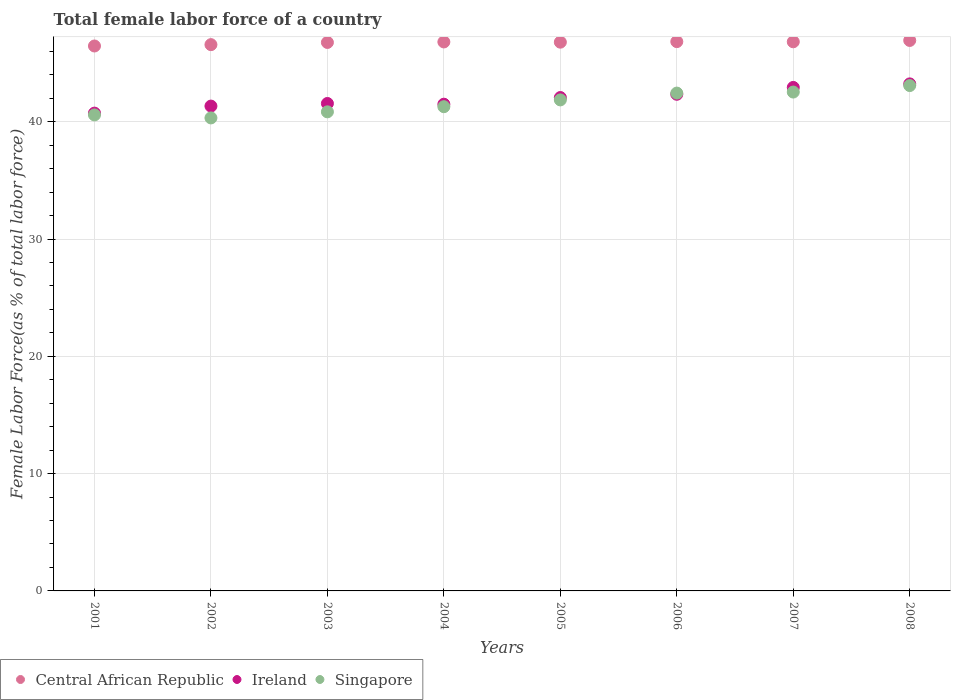Is the number of dotlines equal to the number of legend labels?
Ensure brevity in your answer.  Yes. What is the percentage of female labor force in Ireland in 2003?
Your answer should be compact. 41.55. Across all years, what is the maximum percentage of female labor force in Ireland?
Your answer should be compact. 43.22. Across all years, what is the minimum percentage of female labor force in Central African Republic?
Ensure brevity in your answer.  46.45. What is the total percentage of female labor force in Central African Republic in the graph?
Make the answer very short. 373.93. What is the difference between the percentage of female labor force in Singapore in 2001 and that in 2004?
Ensure brevity in your answer.  -0.7. What is the difference between the percentage of female labor force in Central African Republic in 2006 and the percentage of female labor force in Singapore in 2007?
Your answer should be compact. 4.3. What is the average percentage of female labor force in Central African Republic per year?
Provide a succinct answer. 46.74. In the year 2008, what is the difference between the percentage of female labor force in Singapore and percentage of female labor force in Ireland?
Give a very brief answer. -0.14. In how many years, is the percentage of female labor force in Ireland greater than 26 %?
Your response must be concise. 8. What is the ratio of the percentage of female labor force in Singapore in 2002 to that in 2004?
Offer a very short reply. 0.98. Is the percentage of female labor force in Singapore in 2006 less than that in 2008?
Your answer should be compact. Yes. What is the difference between the highest and the second highest percentage of female labor force in Singapore?
Provide a short and direct response. 0.55. What is the difference between the highest and the lowest percentage of female labor force in Singapore?
Keep it short and to the point. 2.76. In how many years, is the percentage of female labor force in Singapore greater than the average percentage of female labor force in Singapore taken over all years?
Ensure brevity in your answer.  4. Is the sum of the percentage of female labor force in Ireland in 2001 and 2003 greater than the maximum percentage of female labor force in Singapore across all years?
Your answer should be compact. Yes. Is it the case that in every year, the sum of the percentage of female labor force in Central African Republic and percentage of female labor force in Singapore  is greater than the percentage of female labor force in Ireland?
Provide a short and direct response. Yes. Is the percentage of female labor force in Central African Republic strictly greater than the percentage of female labor force in Singapore over the years?
Provide a short and direct response. Yes. How many dotlines are there?
Keep it short and to the point. 3. How many years are there in the graph?
Give a very brief answer. 8. What is the title of the graph?
Offer a terse response. Total female labor force of a country. Does "Chad" appear as one of the legend labels in the graph?
Make the answer very short. No. What is the label or title of the X-axis?
Make the answer very short. Years. What is the label or title of the Y-axis?
Offer a very short reply. Female Labor Force(as % of total labor force). What is the Female Labor Force(as % of total labor force) in Central African Republic in 2001?
Your answer should be very brief. 46.45. What is the Female Labor Force(as % of total labor force) in Ireland in 2001?
Your answer should be compact. 40.73. What is the Female Labor Force(as % of total labor force) of Singapore in 2001?
Provide a short and direct response. 40.58. What is the Female Labor Force(as % of total labor force) in Central African Republic in 2002?
Your answer should be very brief. 46.57. What is the Female Labor Force(as % of total labor force) of Ireland in 2002?
Make the answer very short. 41.33. What is the Female Labor Force(as % of total labor force) of Singapore in 2002?
Offer a terse response. 40.32. What is the Female Labor Force(as % of total labor force) in Central African Republic in 2003?
Offer a terse response. 46.76. What is the Female Labor Force(as % of total labor force) of Ireland in 2003?
Provide a short and direct response. 41.55. What is the Female Labor Force(as % of total labor force) in Singapore in 2003?
Your response must be concise. 40.84. What is the Female Labor Force(as % of total labor force) of Central African Republic in 2004?
Your answer should be compact. 46.8. What is the Female Labor Force(as % of total labor force) in Ireland in 2004?
Offer a terse response. 41.49. What is the Female Labor Force(as % of total labor force) of Singapore in 2004?
Your answer should be compact. 41.28. What is the Female Labor Force(as % of total labor force) of Central African Republic in 2005?
Offer a very short reply. 46.78. What is the Female Labor Force(as % of total labor force) of Ireland in 2005?
Provide a short and direct response. 42.06. What is the Female Labor Force(as % of total labor force) in Singapore in 2005?
Offer a very short reply. 41.86. What is the Female Labor Force(as % of total labor force) of Central African Republic in 2006?
Offer a terse response. 46.83. What is the Female Labor Force(as % of total labor force) in Ireland in 2006?
Provide a succinct answer. 42.34. What is the Female Labor Force(as % of total labor force) in Singapore in 2006?
Make the answer very short. 42.44. What is the Female Labor Force(as % of total labor force) in Central African Republic in 2007?
Your answer should be very brief. 46.81. What is the Female Labor Force(as % of total labor force) in Ireland in 2007?
Ensure brevity in your answer.  42.92. What is the Female Labor Force(as % of total labor force) of Singapore in 2007?
Provide a succinct answer. 42.53. What is the Female Labor Force(as % of total labor force) of Central African Republic in 2008?
Your answer should be compact. 46.93. What is the Female Labor Force(as % of total labor force) of Ireland in 2008?
Your answer should be compact. 43.22. What is the Female Labor Force(as % of total labor force) of Singapore in 2008?
Provide a succinct answer. 43.08. Across all years, what is the maximum Female Labor Force(as % of total labor force) in Central African Republic?
Provide a succinct answer. 46.93. Across all years, what is the maximum Female Labor Force(as % of total labor force) of Ireland?
Keep it short and to the point. 43.22. Across all years, what is the maximum Female Labor Force(as % of total labor force) of Singapore?
Ensure brevity in your answer.  43.08. Across all years, what is the minimum Female Labor Force(as % of total labor force) in Central African Republic?
Offer a terse response. 46.45. Across all years, what is the minimum Female Labor Force(as % of total labor force) of Ireland?
Offer a very short reply. 40.73. Across all years, what is the minimum Female Labor Force(as % of total labor force) of Singapore?
Provide a short and direct response. 40.32. What is the total Female Labor Force(as % of total labor force) in Central African Republic in the graph?
Offer a very short reply. 373.93. What is the total Female Labor Force(as % of total labor force) in Ireland in the graph?
Keep it short and to the point. 335.65. What is the total Female Labor Force(as % of total labor force) in Singapore in the graph?
Give a very brief answer. 332.93. What is the difference between the Female Labor Force(as % of total labor force) of Central African Republic in 2001 and that in 2002?
Your answer should be very brief. -0.11. What is the difference between the Female Labor Force(as % of total labor force) of Ireland in 2001 and that in 2002?
Keep it short and to the point. -0.6. What is the difference between the Female Labor Force(as % of total labor force) of Singapore in 2001 and that in 2002?
Make the answer very short. 0.25. What is the difference between the Female Labor Force(as % of total labor force) in Central African Republic in 2001 and that in 2003?
Offer a terse response. -0.3. What is the difference between the Female Labor Force(as % of total labor force) in Ireland in 2001 and that in 2003?
Provide a short and direct response. -0.82. What is the difference between the Female Labor Force(as % of total labor force) of Singapore in 2001 and that in 2003?
Ensure brevity in your answer.  -0.26. What is the difference between the Female Labor Force(as % of total labor force) in Central African Republic in 2001 and that in 2004?
Give a very brief answer. -0.34. What is the difference between the Female Labor Force(as % of total labor force) in Ireland in 2001 and that in 2004?
Your answer should be very brief. -0.76. What is the difference between the Female Labor Force(as % of total labor force) in Singapore in 2001 and that in 2004?
Your answer should be very brief. -0.7. What is the difference between the Female Labor Force(as % of total labor force) of Central African Republic in 2001 and that in 2005?
Make the answer very short. -0.33. What is the difference between the Female Labor Force(as % of total labor force) of Ireland in 2001 and that in 2005?
Keep it short and to the point. -1.33. What is the difference between the Female Labor Force(as % of total labor force) in Singapore in 2001 and that in 2005?
Your answer should be compact. -1.28. What is the difference between the Female Labor Force(as % of total labor force) of Central African Republic in 2001 and that in 2006?
Give a very brief answer. -0.37. What is the difference between the Female Labor Force(as % of total labor force) of Ireland in 2001 and that in 2006?
Your answer should be compact. -1.61. What is the difference between the Female Labor Force(as % of total labor force) in Singapore in 2001 and that in 2006?
Ensure brevity in your answer.  -1.86. What is the difference between the Female Labor Force(as % of total labor force) in Central African Republic in 2001 and that in 2007?
Ensure brevity in your answer.  -0.36. What is the difference between the Female Labor Force(as % of total labor force) of Ireland in 2001 and that in 2007?
Give a very brief answer. -2.19. What is the difference between the Female Labor Force(as % of total labor force) in Singapore in 2001 and that in 2007?
Offer a terse response. -1.95. What is the difference between the Female Labor Force(as % of total labor force) of Central African Republic in 2001 and that in 2008?
Provide a succinct answer. -0.47. What is the difference between the Female Labor Force(as % of total labor force) in Ireland in 2001 and that in 2008?
Ensure brevity in your answer.  -2.49. What is the difference between the Female Labor Force(as % of total labor force) in Singapore in 2001 and that in 2008?
Keep it short and to the point. -2.5. What is the difference between the Female Labor Force(as % of total labor force) in Central African Republic in 2002 and that in 2003?
Your response must be concise. -0.19. What is the difference between the Female Labor Force(as % of total labor force) in Ireland in 2002 and that in 2003?
Your response must be concise. -0.22. What is the difference between the Female Labor Force(as % of total labor force) of Singapore in 2002 and that in 2003?
Give a very brief answer. -0.52. What is the difference between the Female Labor Force(as % of total labor force) of Central African Republic in 2002 and that in 2004?
Keep it short and to the point. -0.23. What is the difference between the Female Labor Force(as % of total labor force) of Ireland in 2002 and that in 2004?
Ensure brevity in your answer.  -0.16. What is the difference between the Female Labor Force(as % of total labor force) of Singapore in 2002 and that in 2004?
Offer a terse response. -0.96. What is the difference between the Female Labor Force(as % of total labor force) in Central African Republic in 2002 and that in 2005?
Offer a very short reply. -0.21. What is the difference between the Female Labor Force(as % of total labor force) in Ireland in 2002 and that in 2005?
Provide a succinct answer. -0.73. What is the difference between the Female Labor Force(as % of total labor force) of Singapore in 2002 and that in 2005?
Your answer should be compact. -1.53. What is the difference between the Female Labor Force(as % of total labor force) of Central African Republic in 2002 and that in 2006?
Keep it short and to the point. -0.26. What is the difference between the Female Labor Force(as % of total labor force) of Ireland in 2002 and that in 2006?
Provide a short and direct response. -1.01. What is the difference between the Female Labor Force(as % of total labor force) in Singapore in 2002 and that in 2006?
Give a very brief answer. -2.12. What is the difference between the Female Labor Force(as % of total labor force) in Central African Republic in 2002 and that in 2007?
Provide a succinct answer. -0.24. What is the difference between the Female Labor Force(as % of total labor force) of Ireland in 2002 and that in 2007?
Provide a succinct answer. -1.59. What is the difference between the Female Labor Force(as % of total labor force) of Singapore in 2002 and that in 2007?
Your answer should be compact. -2.2. What is the difference between the Female Labor Force(as % of total labor force) of Central African Republic in 2002 and that in 2008?
Ensure brevity in your answer.  -0.36. What is the difference between the Female Labor Force(as % of total labor force) of Ireland in 2002 and that in 2008?
Your answer should be very brief. -1.89. What is the difference between the Female Labor Force(as % of total labor force) in Singapore in 2002 and that in 2008?
Make the answer very short. -2.76. What is the difference between the Female Labor Force(as % of total labor force) in Central African Republic in 2003 and that in 2004?
Make the answer very short. -0.04. What is the difference between the Female Labor Force(as % of total labor force) in Singapore in 2003 and that in 2004?
Give a very brief answer. -0.44. What is the difference between the Female Labor Force(as % of total labor force) in Central African Republic in 2003 and that in 2005?
Your response must be concise. -0.02. What is the difference between the Female Labor Force(as % of total labor force) in Ireland in 2003 and that in 2005?
Provide a succinct answer. -0.51. What is the difference between the Female Labor Force(as % of total labor force) of Singapore in 2003 and that in 2005?
Keep it short and to the point. -1.02. What is the difference between the Female Labor Force(as % of total labor force) of Central African Republic in 2003 and that in 2006?
Make the answer very short. -0.07. What is the difference between the Female Labor Force(as % of total labor force) in Ireland in 2003 and that in 2006?
Your answer should be very brief. -0.78. What is the difference between the Female Labor Force(as % of total labor force) of Singapore in 2003 and that in 2006?
Keep it short and to the point. -1.6. What is the difference between the Female Labor Force(as % of total labor force) of Central African Republic in 2003 and that in 2007?
Keep it short and to the point. -0.06. What is the difference between the Female Labor Force(as % of total labor force) of Ireland in 2003 and that in 2007?
Your response must be concise. -1.37. What is the difference between the Female Labor Force(as % of total labor force) in Singapore in 2003 and that in 2007?
Provide a short and direct response. -1.69. What is the difference between the Female Labor Force(as % of total labor force) of Central African Republic in 2003 and that in 2008?
Keep it short and to the point. -0.17. What is the difference between the Female Labor Force(as % of total labor force) of Ireland in 2003 and that in 2008?
Provide a succinct answer. -1.67. What is the difference between the Female Labor Force(as % of total labor force) of Singapore in 2003 and that in 2008?
Your answer should be very brief. -2.24. What is the difference between the Female Labor Force(as % of total labor force) of Central African Republic in 2004 and that in 2005?
Ensure brevity in your answer.  0.02. What is the difference between the Female Labor Force(as % of total labor force) of Ireland in 2004 and that in 2005?
Your answer should be very brief. -0.57. What is the difference between the Female Labor Force(as % of total labor force) of Singapore in 2004 and that in 2005?
Provide a short and direct response. -0.58. What is the difference between the Female Labor Force(as % of total labor force) of Central African Republic in 2004 and that in 2006?
Offer a very short reply. -0.03. What is the difference between the Female Labor Force(as % of total labor force) of Ireland in 2004 and that in 2006?
Give a very brief answer. -0.84. What is the difference between the Female Labor Force(as % of total labor force) in Singapore in 2004 and that in 2006?
Provide a short and direct response. -1.16. What is the difference between the Female Labor Force(as % of total labor force) of Central African Republic in 2004 and that in 2007?
Make the answer very short. -0.01. What is the difference between the Female Labor Force(as % of total labor force) in Ireland in 2004 and that in 2007?
Offer a very short reply. -1.43. What is the difference between the Female Labor Force(as % of total labor force) of Singapore in 2004 and that in 2007?
Give a very brief answer. -1.25. What is the difference between the Female Labor Force(as % of total labor force) in Central African Republic in 2004 and that in 2008?
Offer a terse response. -0.13. What is the difference between the Female Labor Force(as % of total labor force) of Ireland in 2004 and that in 2008?
Your response must be concise. -1.73. What is the difference between the Female Labor Force(as % of total labor force) in Singapore in 2004 and that in 2008?
Ensure brevity in your answer.  -1.8. What is the difference between the Female Labor Force(as % of total labor force) of Central African Republic in 2005 and that in 2006?
Keep it short and to the point. -0.05. What is the difference between the Female Labor Force(as % of total labor force) of Ireland in 2005 and that in 2006?
Your response must be concise. -0.28. What is the difference between the Female Labor Force(as % of total labor force) in Singapore in 2005 and that in 2006?
Offer a very short reply. -0.58. What is the difference between the Female Labor Force(as % of total labor force) of Central African Republic in 2005 and that in 2007?
Ensure brevity in your answer.  -0.03. What is the difference between the Female Labor Force(as % of total labor force) of Ireland in 2005 and that in 2007?
Your answer should be very brief. -0.86. What is the difference between the Female Labor Force(as % of total labor force) in Singapore in 2005 and that in 2007?
Ensure brevity in your answer.  -0.67. What is the difference between the Female Labor Force(as % of total labor force) in Central African Republic in 2005 and that in 2008?
Provide a short and direct response. -0.15. What is the difference between the Female Labor Force(as % of total labor force) of Ireland in 2005 and that in 2008?
Your answer should be very brief. -1.16. What is the difference between the Female Labor Force(as % of total labor force) of Singapore in 2005 and that in 2008?
Ensure brevity in your answer.  -1.22. What is the difference between the Female Labor Force(as % of total labor force) of Central African Republic in 2006 and that in 2007?
Keep it short and to the point. 0.01. What is the difference between the Female Labor Force(as % of total labor force) of Ireland in 2006 and that in 2007?
Offer a terse response. -0.58. What is the difference between the Female Labor Force(as % of total labor force) in Singapore in 2006 and that in 2007?
Make the answer very short. -0.09. What is the difference between the Female Labor Force(as % of total labor force) of Central African Republic in 2006 and that in 2008?
Offer a very short reply. -0.1. What is the difference between the Female Labor Force(as % of total labor force) in Ireland in 2006 and that in 2008?
Offer a terse response. -0.89. What is the difference between the Female Labor Force(as % of total labor force) in Singapore in 2006 and that in 2008?
Provide a succinct answer. -0.64. What is the difference between the Female Labor Force(as % of total labor force) in Central African Republic in 2007 and that in 2008?
Make the answer very short. -0.11. What is the difference between the Female Labor Force(as % of total labor force) of Ireland in 2007 and that in 2008?
Offer a terse response. -0.3. What is the difference between the Female Labor Force(as % of total labor force) in Singapore in 2007 and that in 2008?
Your response must be concise. -0.55. What is the difference between the Female Labor Force(as % of total labor force) in Central African Republic in 2001 and the Female Labor Force(as % of total labor force) in Ireland in 2002?
Your answer should be compact. 5.12. What is the difference between the Female Labor Force(as % of total labor force) of Central African Republic in 2001 and the Female Labor Force(as % of total labor force) of Singapore in 2002?
Give a very brief answer. 6.13. What is the difference between the Female Labor Force(as % of total labor force) in Ireland in 2001 and the Female Labor Force(as % of total labor force) in Singapore in 2002?
Your answer should be very brief. 0.41. What is the difference between the Female Labor Force(as % of total labor force) in Central African Republic in 2001 and the Female Labor Force(as % of total labor force) in Ireland in 2003?
Provide a succinct answer. 4.9. What is the difference between the Female Labor Force(as % of total labor force) in Central African Republic in 2001 and the Female Labor Force(as % of total labor force) in Singapore in 2003?
Offer a terse response. 5.61. What is the difference between the Female Labor Force(as % of total labor force) in Ireland in 2001 and the Female Labor Force(as % of total labor force) in Singapore in 2003?
Offer a terse response. -0.11. What is the difference between the Female Labor Force(as % of total labor force) in Central African Republic in 2001 and the Female Labor Force(as % of total labor force) in Ireland in 2004?
Make the answer very short. 4.96. What is the difference between the Female Labor Force(as % of total labor force) in Central African Republic in 2001 and the Female Labor Force(as % of total labor force) in Singapore in 2004?
Make the answer very short. 5.18. What is the difference between the Female Labor Force(as % of total labor force) of Ireland in 2001 and the Female Labor Force(as % of total labor force) of Singapore in 2004?
Your answer should be very brief. -0.55. What is the difference between the Female Labor Force(as % of total labor force) of Central African Republic in 2001 and the Female Labor Force(as % of total labor force) of Ireland in 2005?
Your answer should be very brief. 4.39. What is the difference between the Female Labor Force(as % of total labor force) in Central African Republic in 2001 and the Female Labor Force(as % of total labor force) in Singapore in 2005?
Make the answer very short. 4.6. What is the difference between the Female Labor Force(as % of total labor force) of Ireland in 2001 and the Female Labor Force(as % of total labor force) of Singapore in 2005?
Provide a succinct answer. -1.13. What is the difference between the Female Labor Force(as % of total labor force) in Central African Republic in 2001 and the Female Labor Force(as % of total labor force) in Ireland in 2006?
Your response must be concise. 4.12. What is the difference between the Female Labor Force(as % of total labor force) of Central African Republic in 2001 and the Female Labor Force(as % of total labor force) of Singapore in 2006?
Provide a short and direct response. 4.01. What is the difference between the Female Labor Force(as % of total labor force) in Ireland in 2001 and the Female Labor Force(as % of total labor force) in Singapore in 2006?
Keep it short and to the point. -1.71. What is the difference between the Female Labor Force(as % of total labor force) of Central African Republic in 2001 and the Female Labor Force(as % of total labor force) of Ireland in 2007?
Keep it short and to the point. 3.53. What is the difference between the Female Labor Force(as % of total labor force) in Central African Republic in 2001 and the Female Labor Force(as % of total labor force) in Singapore in 2007?
Your response must be concise. 3.93. What is the difference between the Female Labor Force(as % of total labor force) of Ireland in 2001 and the Female Labor Force(as % of total labor force) of Singapore in 2007?
Offer a terse response. -1.8. What is the difference between the Female Labor Force(as % of total labor force) of Central African Republic in 2001 and the Female Labor Force(as % of total labor force) of Ireland in 2008?
Ensure brevity in your answer.  3.23. What is the difference between the Female Labor Force(as % of total labor force) of Central African Republic in 2001 and the Female Labor Force(as % of total labor force) of Singapore in 2008?
Make the answer very short. 3.37. What is the difference between the Female Labor Force(as % of total labor force) of Ireland in 2001 and the Female Labor Force(as % of total labor force) of Singapore in 2008?
Your response must be concise. -2.35. What is the difference between the Female Labor Force(as % of total labor force) in Central African Republic in 2002 and the Female Labor Force(as % of total labor force) in Ireland in 2003?
Provide a succinct answer. 5.02. What is the difference between the Female Labor Force(as % of total labor force) of Central African Republic in 2002 and the Female Labor Force(as % of total labor force) of Singapore in 2003?
Offer a very short reply. 5.73. What is the difference between the Female Labor Force(as % of total labor force) of Ireland in 2002 and the Female Labor Force(as % of total labor force) of Singapore in 2003?
Ensure brevity in your answer.  0.49. What is the difference between the Female Labor Force(as % of total labor force) of Central African Republic in 2002 and the Female Labor Force(as % of total labor force) of Ireland in 2004?
Offer a terse response. 5.08. What is the difference between the Female Labor Force(as % of total labor force) in Central African Republic in 2002 and the Female Labor Force(as % of total labor force) in Singapore in 2004?
Provide a short and direct response. 5.29. What is the difference between the Female Labor Force(as % of total labor force) of Ireland in 2002 and the Female Labor Force(as % of total labor force) of Singapore in 2004?
Offer a terse response. 0.05. What is the difference between the Female Labor Force(as % of total labor force) in Central African Republic in 2002 and the Female Labor Force(as % of total labor force) in Ireland in 2005?
Provide a short and direct response. 4.51. What is the difference between the Female Labor Force(as % of total labor force) of Central African Republic in 2002 and the Female Labor Force(as % of total labor force) of Singapore in 2005?
Ensure brevity in your answer.  4.71. What is the difference between the Female Labor Force(as % of total labor force) in Ireland in 2002 and the Female Labor Force(as % of total labor force) in Singapore in 2005?
Keep it short and to the point. -0.53. What is the difference between the Female Labor Force(as % of total labor force) in Central African Republic in 2002 and the Female Labor Force(as % of total labor force) in Ireland in 2006?
Your answer should be compact. 4.23. What is the difference between the Female Labor Force(as % of total labor force) of Central African Republic in 2002 and the Female Labor Force(as % of total labor force) of Singapore in 2006?
Keep it short and to the point. 4.13. What is the difference between the Female Labor Force(as % of total labor force) in Ireland in 2002 and the Female Labor Force(as % of total labor force) in Singapore in 2006?
Make the answer very short. -1.11. What is the difference between the Female Labor Force(as % of total labor force) of Central African Republic in 2002 and the Female Labor Force(as % of total labor force) of Ireland in 2007?
Ensure brevity in your answer.  3.65. What is the difference between the Female Labor Force(as % of total labor force) in Central African Republic in 2002 and the Female Labor Force(as % of total labor force) in Singapore in 2007?
Your answer should be compact. 4.04. What is the difference between the Female Labor Force(as % of total labor force) of Ireland in 2002 and the Female Labor Force(as % of total labor force) of Singapore in 2007?
Your response must be concise. -1.2. What is the difference between the Female Labor Force(as % of total labor force) of Central African Republic in 2002 and the Female Labor Force(as % of total labor force) of Ireland in 2008?
Ensure brevity in your answer.  3.35. What is the difference between the Female Labor Force(as % of total labor force) in Central African Republic in 2002 and the Female Labor Force(as % of total labor force) in Singapore in 2008?
Ensure brevity in your answer.  3.49. What is the difference between the Female Labor Force(as % of total labor force) in Ireland in 2002 and the Female Labor Force(as % of total labor force) in Singapore in 2008?
Your answer should be compact. -1.75. What is the difference between the Female Labor Force(as % of total labor force) in Central African Republic in 2003 and the Female Labor Force(as % of total labor force) in Ireland in 2004?
Your answer should be compact. 5.26. What is the difference between the Female Labor Force(as % of total labor force) of Central African Republic in 2003 and the Female Labor Force(as % of total labor force) of Singapore in 2004?
Your response must be concise. 5.48. What is the difference between the Female Labor Force(as % of total labor force) of Ireland in 2003 and the Female Labor Force(as % of total labor force) of Singapore in 2004?
Keep it short and to the point. 0.27. What is the difference between the Female Labor Force(as % of total labor force) in Central African Republic in 2003 and the Female Labor Force(as % of total labor force) in Ireland in 2005?
Keep it short and to the point. 4.7. What is the difference between the Female Labor Force(as % of total labor force) in Central African Republic in 2003 and the Female Labor Force(as % of total labor force) in Singapore in 2005?
Provide a short and direct response. 4.9. What is the difference between the Female Labor Force(as % of total labor force) of Ireland in 2003 and the Female Labor Force(as % of total labor force) of Singapore in 2005?
Offer a terse response. -0.3. What is the difference between the Female Labor Force(as % of total labor force) in Central African Republic in 2003 and the Female Labor Force(as % of total labor force) in Ireland in 2006?
Your answer should be compact. 4.42. What is the difference between the Female Labor Force(as % of total labor force) of Central African Republic in 2003 and the Female Labor Force(as % of total labor force) of Singapore in 2006?
Make the answer very short. 4.32. What is the difference between the Female Labor Force(as % of total labor force) of Ireland in 2003 and the Female Labor Force(as % of total labor force) of Singapore in 2006?
Your answer should be compact. -0.89. What is the difference between the Female Labor Force(as % of total labor force) in Central African Republic in 2003 and the Female Labor Force(as % of total labor force) in Ireland in 2007?
Keep it short and to the point. 3.83. What is the difference between the Female Labor Force(as % of total labor force) in Central African Republic in 2003 and the Female Labor Force(as % of total labor force) in Singapore in 2007?
Keep it short and to the point. 4.23. What is the difference between the Female Labor Force(as % of total labor force) in Ireland in 2003 and the Female Labor Force(as % of total labor force) in Singapore in 2007?
Your response must be concise. -0.97. What is the difference between the Female Labor Force(as % of total labor force) of Central African Republic in 2003 and the Female Labor Force(as % of total labor force) of Ireland in 2008?
Ensure brevity in your answer.  3.53. What is the difference between the Female Labor Force(as % of total labor force) in Central African Republic in 2003 and the Female Labor Force(as % of total labor force) in Singapore in 2008?
Provide a succinct answer. 3.68. What is the difference between the Female Labor Force(as % of total labor force) in Ireland in 2003 and the Female Labor Force(as % of total labor force) in Singapore in 2008?
Ensure brevity in your answer.  -1.53. What is the difference between the Female Labor Force(as % of total labor force) of Central African Republic in 2004 and the Female Labor Force(as % of total labor force) of Ireland in 2005?
Your response must be concise. 4.74. What is the difference between the Female Labor Force(as % of total labor force) of Central African Republic in 2004 and the Female Labor Force(as % of total labor force) of Singapore in 2005?
Keep it short and to the point. 4.94. What is the difference between the Female Labor Force(as % of total labor force) in Ireland in 2004 and the Female Labor Force(as % of total labor force) in Singapore in 2005?
Your response must be concise. -0.36. What is the difference between the Female Labor Force(as % of total labor force) in Central African Republic in 2004 and the Female Labor Force(as % of total labor force) in Ireland in 2006?
Make the answer very short. 4.46. What is the difference between the Female Labor Force(as % of total labor force) of Central African Republic in 2004 and the Female Labor Force(as % of total labor force) of Singapore in 2006?
Keep it short and to the point. 4.36. What is the difference between the Female Labor Force(as % of total labor force) of Ireland in 2004 and the Female Labor Force(as % of total labor force) of Singapore in 2006?
Keep it short and to the point. -0.95. What is the difference between the Female Labor Force(as % of total labor force) in Central African Republic in 2004 and the Female Labor Force(as % of total labor force) in Ireland in 2007?
Offer a terse response. 3.88. What is the difference between the Female Labor Force(as % of total labor force) in Central African Republic in 2004 and the Female Labor Force(as % of total labor force) in Singapore in 2007?
Make the answer very short. 4.27. What is the difference between the Female Labor Force(as % of total labor force) of Ireland in 2004 and the Female Labor Force(as % of total labor force) of Singapore in 2007?
Offer a terse response. -1.03. What is the difference between the Female Labor Force(as % of total labor force) of Central African Republic in 2004 and the Female Labor Force(as % of total labor force) of Ireland in 2008?
Offer a terse response. 3.58. What is the difference between the Female Labor Force(as % of total labor force) in Central African Republic in 2004 and the Female Labor Force(as % of total labor force) in Singapore in 2008?
Make the answer very short. 3.72. What is the difference between the Female Labor Force(as % of total labor force) in Ireland in 2004 and the Female Labor Force(as % of total labor force) in Singapore in 2008?
Offer a terse response. -1.59. What is the difference between the Female Labor Force(as % of total labor force) in Central African Republic in 2005 and the Female Labor Force(as % of total labor force) in Ireland in 2006?
Offer a very short reply. 4.44. What is the difference between the Female Labor Force(as % of total labor force) in Central African Republic in 2005 and the Female Labor Force(as % of total labor force) in Singapore in 2006?
Give a very brief answer. 4.34. What is the difference between the Female Labor Force(as % of total labor force) of Ireland in 2005 and the Female Labor Force(as % of total labor force) of Singapore in 2006?
Your answer should be compact. -0.38. What is the difference between the Female Labor Force(as % of total labor force) in Central African Republic in 2005 and the Female Labor Force(as % of total labor force) in Ireland in 2007?
Offer a terse response. 3.86. What is the difference between the Female Labor Force(as % of total labor force) of Central African Republic in 2005 and the Female Labor Force(as % of total labor force) of Singapore in 2007?
Provide a succinct answer. 4.25. What is the difference between the Female Labor Force(as % of total labor force) of Ireland in 2005 and the Female Labor Force(as % of total labor force) of Singapore in 2007?
Provide a short and direct response. -0.47. What is the difference between the Female Labor Force(as % of total labor force) in Central African Republic in 2005 and the Female Labor Force(as % of total labor force) in Ireland in 2008?
Provide a succinct answer. 3.56. What is the difference between the Female Labor Force(as % of total labor force) in Central African Republic in 2005 and the Female Labor Force(as % of total labor force) in Singapore in 2008?
Your answer should be very brief. 3.7. What is the difference between the Female Labor Force(as % of total labor force) in Ireland in 2005 and the Female Labor Force(as % of total labor force) in Singapore in 2008?
Give a very brief answer. -1.02. What is the difference between the Female Labor Force(as % of total labor force) of Central African Republic in 2006 and the Female Labor Force(as % of total labor force) of Ireland in 2007?
Ensure brevity in your answer.  3.91. What is the difference between the Female Labor Force(as % of total labor force) in Central African Republic in 2006 and the Female Labor Force(as % of total labor force) in Singapore in 2007?
Offer a very short reply. 4.3. What is the difference between the Female Labor Force(as % of total labor force) of Ireland in 2006 and the Female Labor Force(as % of total labor force) of Singapore in 2007?
Offer a terse response. -0.19. What is the difference between the Female Labor Force(as % of total labor force) in Central African Republic in 2006 and the Female Labor Force(as % of total labor force) in Ireland in 2008?
Ensure brevity in your answer.  3.6. What is the difference between the Female Labor Force(as % of total labor force) of Central African Republic in 2006 and the Female Labor Force(as % of total labor force) of Singapore in 2008?
Keep it short and to the point. 3.75. What is the difference between the Female Labor Force(as % of total labor force) in Ireland in 2006 and the Female Labor Force(as % of total labor force) in Singapore in 2008?
Offer a terse response. -0.74. What is the difference between the Female Labor Force(as % of total labor force) in Central African Republic in 2007 and the Female Labor Force(as % of total labor force) in Ireland in 2008?
Provide a short and direct response. 3.59. What is the difference between the Female Labor Force(as % of total labor force) of Central African Republic in 2007 and the Female Labor Force(as % of total labor force) of Singapore in 2008?
Your answer should be very brief. 3.73. What is the difference between the Female Labor Force(as % of total labor force) of Ireland in 2007 and the Female Labor Force(as % of total labor force) of Singapore in 2008?
Make the answer very short. -0.16. What is the average Female Labor Force(as % of total labor force) of Central African Republic per year?
Make the answer very short. 46.74. What is the average Female Labor Force(as % of total labor force) in Ireland per year?
Your response must be concise. 41.96. What is the average Female Labor Force(as % of total labor force) in Singapore per year?
Offer a terse response. 41.62. In the year 2001, what is the difference between the Female Labor Force(as % of total labor force) of Central African Republic and Female Labor Force(as % of total labor force) of Ireland?
Your answer should be very brief. 5.72. In the year 2001, what is the difference between the Female Labor Force(as % of total labor force) of Central African Republic and Female Labor Force(as % of total labor force) of Singapore?
Your answer should be very brief. 5.88. In the year 2001, what is the difference between the Female Labor Force(as % of total labor force) in Ireland and Female Labor Force(as % of total labor force) in Singapore?
Your response must be concise. 0.15. In the year 2002, what is the difference between the Female Labor Force(as % of total labor force) in Central African Republic and Female Labor Force(as % of total labor force) in Ireland?
Your response must be concise. 5.24. In the year 2002, what is the difference between the Female Labor Force(as % of total labor force) of Central African Republic and Female Labor Force(as % of total labor force) of Singapore?
Offer a terse response. 6.25. In the year 2002, what is the difference between the Female Labor Force(as % of total labor force) in Ireland and Female Labor Force(as % of total labor force) in Singapore?
Keep it short and to the point. 1.01. In the year 2003, what is the difference between the Female Labor Force(as % of total labor force) in Central African Republic and Female Labor Force(as % of total labor force) in Ireland?
Your answer should be compact. 5.2. In the year 2003, what is the difference between the Female Labor Force(as % of total labor force) of Central African Republic and Female Labor Force(as % of total labor force) of Singapore?
Keep it short and to the point. 5.92. In the year 2003, what is the difference between the Female Labor Force(as % of total labor force) of Ireland and Female Labor Force(as % of total labor force) of Singapore?
Offer a terse response. 0.71. In the year 2004, what is the difference between the Female Labor Force(as % of total labor force) in Central African Republic and Female Labor Force(as % of total labor force) in Ireland?
Your response must be concise. 5.31. In the year 2004, what is the difference between the Female Labor Force(as % of total labor force) of Central African Republic and Female Labor Force(as % of total labor force) of Singapore?
Offer a terse response. 5.52. In the year 2004, what is the difference between the Female Labor Force(as % of total labor force) of Ireland and Female Labor Force(as % of total labor force) of Singapore?
Offer a terse response. 0.21. In the year 2005, what is the difference between the Female Labor Force(as % of total labor force) in Central African Republic and Female Labor Force(as % of total labor force) in Ireland?
Your response must be concise. 4.72. In the year 2005, what is the difference between the Female Labor Force(as % of total labor force) in Central African Republic and Female Labor Force(as % of total labor force) in Singapore?
Give a very brief answer. 4.92. In the year 2005, what is the difference between the Female Labor Force(as % of total labor force) in Ireland and Female Labor Force(as % of total labor force) in Singapore?
Give a very brief answer. 0.2. In the year 2006, what is the difference between the Female Labor Force(as % of total labor force) in Central African Republic and Female Labor Force(as % of total labor force) in Ireland?
Keep it short and to the point. 4.49. In the year 2006, what is the difference between the Female Labor Force(as % of total labor force) of Central African Republic and Female Labor Force(as % of total labor force) of Singapore?
Provide a short and direct response. 4.39. In the year 2006, what is the difference between the Female Labor Force(as % of total labor force) in Ireland and Female Labor Force(as % of total labor force) in Singapore?
Provide a short and direct response. -0.1. In the year 2007, what is the difference between the Female Labor Force(as % of total labor force) of Central African Republic and Female Labor Force(as % of total labor force) of Ireland?
Provide a short and direct response. 3.89. In the year 2007, what is the difference between the Female Labor Force(as % of total labor force) of Central African Republic and Female Labor Force(as % of total labor force) of Singapore?
Your answer should be compact. 4.29. In the year 2007, what is the difference between the Female Labor Force(as % of total labor force) of Ireland and Female Labor Force(as % of total labor force) of Singapore?
Offer a very short reply. 0.39. In the year 2008, what is the difference between the Female Labor Force(as % of total labor force) of Central African Republic and Female Labor Force(as % of total labor force) of Ireland?
Make the answer very short. 3.7. In the year 2008, what is the difference between the Female Labor Force(as % of total labor force) in Central African Republic and Female Labor Force(as % of total labor force) in Singapore?
Keep it short and to the point. 3.85. In the year 2008, what is the difference between the Female Labor Force(as % of total labor force) of Ireland and Female Labor Force(as % of total labor force) of Singapore?
Provide a short and direct response. 0.14. What is the ratio of the Female Labor Force(as % of total labor force) of Central African Republic in 2001 to that in 2002?
Your answer should be compact. 1. What is the ratio of the Female Labor Force(as % of total labor force) of Ireland in 2001 to that in 2002?
Give a very brief answer. 0.99. What is the ratio of the Female Labor Force(as % of total labor force) in Central African Republic in 2001 to that in 2003?
Offer a terse response. 0.99. What is the ratio of the Female Labor Force(as % of total labor force) of Ireland in 2001 to that in 2003?
Your response must be concise. 0.98. What is the ratio of the Female Labor Force(as % of total labor force) of Singapore in 2001 to that in 2003?
Provide a short and direct response. 0.99. What is the ratio of the Female Labor Force(as % of total labor force) of Ireland in 2001 to that in 2004?
Make the answer very short. 0.98. What is the ratio of the Female Labor Force(as % of total labor force) of Singapore in 2001 to that in 2004?
Make the answer very short. 0.98. What is the ratio of the Female Labor Force(as % of total labor force) in Ireland in 2001 to that in 2005?
Give a very brief answer. 0.97. What is the ratio of the Female Labor Force(as % of total labor force) in Singapore in 2001 to that in 2005?
Give a very brief answer. 0.97. What is the ratio of the Female Labor Force(as % of total labor force) of Central African Republic in 2001 to that in 2006?
Your answer should be very brief. 0.99. What is the ratio of the Female Labor Force(as % of total labor force) of Ireland in 2001 to that in 2006?
Your answer should be very brief. 0.96. What is the ratio of the Female Labor Force(as % of total labor force) of Singapore in 2001 to that in 2006?
Your answer should be very brief. 0.96. What is the ratio of the Female Labor Force(as % of total labor force) of Central African Republic in 2001 to that in 2007?
Provide a short and direct response. 0.99. What is the ratio of the Female Labor Force(as % of total labor force) of Ireland in 2001 to that in 2007?
Give a very brief answer. 0.95. What is the ratio of the Female Labor Force(as % of total labor force) in Singapore in 2001 to that in 2007?
Provide a short and direct response. 0.95. What is the ratio of the Female Labor Force(as % of total labor force) in Ireland in 2001 to that in 2008?
Offer a terse response. 0.94. What is the ratio of the Female Labor Force(as % of total labor force) of Singapore in 2001 to that in 2008?
Keep it short and to the point. 0.94. What is the ratio of the Female Labor Force(as % of total labor force) of Singapore in 2002 to that in 2003?
Offer a terse response. 0.99. What is the ratio of the Female Labor Force(as % of total labor force) in Central African Republic in 2002 to that in 2004?
Provide a short and direct response. 1. What is the ratio of the Female Labor Force(as % of total labor force) of Singapore in 2002 to that in 2004?
Your response must be concise. 0.98. What is the ratio of the Female Labor Force(as % of total labor force) in Central African Republic in 2002 to that in 2005?
Your answer should be compact. 1. What is the ratio of the Female Labor Force(as % of total labor force) of Ireland in 2002 to that in 2005?
Your answer should be very brief. 0.98. What is the ratio of the Female Labor Force(as % of total labor force) of Singapore in 2002 to that in 2005?
Give a very brief answer. 0.96. What is the ratio of the Female Labor Force(as % of total labor force) of Central African Republic in 2002 to that in 2006?
Keep it short and to the point. 0.99. What is the ratio of the Female Labor Force(as % of total labor force) in Ireland in 2002 to that in 2006?
Provide a succinct answer. 0.98. What is the ratio of the Female Labor Force(as % of total labor force) in Singapore in 2002 to that in 2006?
Give a very brief answer. 0.95. What is the ratio of the Female Labor Force(as % of total labor force) in Ireland in 2002 to that in 2007?
Give a very brief answer. 0.96. What is the ratio of the Female Labor Force(as % of total labor force) of Singapore in 2002 to that in 2007?
Offer a very short reply. 0.95. What is the ratio of the Female Labor Force(as % of total labor force) in Central African Republic in 2002 to that in 2008?
Keep it short and to the point. 0.99. What is the ratio of the Female Labor Force(as % of total labor force) in Ireland in 2002 to that in 2008?
Your answer should be compact. 0.96. What is the ratio of the Female Labor Force(as % of total labor force) in Singapore in 2002 to that in 2008?
Ensure brevity in your answer.  0.94. What is the ratio of the Female Labor Force(as % of total labor force) in Ireland in 2003 to that in 2004?
Your answer should be compact. 1. What is the ratio of the Female Labor Force(as % of total labor force) in Singapore in 2003 to that in 2005?
Offer a terse response. 0.98. What is the ratio of the Female Labor Force(as % of total labor force) of Ireland in 2003 to that in 2006?
Keep it short and to the point. 0.98. What is the ratio of the Female Labor Force(as % of total labor force) of Singapore in 2003 to that in 2006?
Give a very brief answer. 0.96. What is the ratio of the Female Labor Force(as % of total labor force) in Central African Republic in 2003 to that in 2007?
Your answer should be compact. 1. What is the ratio of the Female Labor Force(as % of total labor force) of Ireland in 2003 to that in 2007?
Keep it short and to the point. 0.97. What is the ratio of the Female Labor Force(as % of total labor force) in Singapore in 2003 to that in 2007?
Give a very brief answer. 0.96. What is the ratio of the Female Labor Force(as % of total labor force) of Ireland in 2003 to that in 2008?
Keep it short and to the point. 0.96. What is the ratio of the Female Labor Force(as % of total labor force) of Singapore in 2003 to that in 2008?
Provide a succinct answer. 0.95. What is the ratio of the Female Labor Force(as % of total labor force) of Ireland in 2004 to that in 2005?
Your response must be concise. 0.99. What is the ratio of the Female Labor Force(as % of total labor force) of Singapore in 2004 to that in 2005?
Provide a short and direct response. 0.99. What is the ratio of the Female Labor Force(as % of total labor force) in Central African Republic in 2004 to that in 2006?
Make the answer very short. 1. What is the ratio of the Female Labor Force(as % of total labor force) of Singapore in 2004 to that in 2006?
Make the answer very short. 0.97. What is the ratio of the Female Labor Force(as % of total labor force) of Ireland in 2004 to that in 2007?
Your answer should be very brief. 0.97. What is the ratio of the Female Labor Force(as % of total labor force) of Singapore in 2004 to that in 2007?
Provide a short and direct response. 0.97. What is the ratio of the Female Labor Force(as % of total labor force) in Central African Republic in 2004 to that in 2008?
Provide a succinct answer. 1. What is the ratio of the Female Labor Force(as % of total labor force) in Ireland in 2004 to that in 2008?
Give a very brief answer. 0.96. What is the ratio of the Female Labor Force(as % of total labor force) of Singapore in 2004 to that in 2008?
Provide a short and direct response. 0.96. What is the ratio of the Female Labor Force(as % of total labor force) in Singapore in 2005 to that in 2006?
Provide a short and direct response. 0.99. What is the ratio of the Female Labor Force(as % of total labor force) of Central African Republic in 2005 to that in 2007?
Provide a succinct answer. 1. What is the ratio of the Female Labor Force(as % of total labor force) in Ireland in 2005 to that in 2007?
Your response must be concise. 0.98. What is the ratio of the Female Labor Force(as % of total labor force) of Singapore in 2005 to that in 2007?
Make the answer very short. 0.98. What is the ratio of the Female Labor Force(as % of total labor force) in Ireland in 2005 to that in 2008?
Ensure brevity in your answer.  0.97. What is the ratio of the Female Labor Force(as % of total labor force) in Singapore in 2005 to that in 2008?
Your answer should be very brief. 0.97. What is the ratio of the Female Labor Force(as % of total labor force) of Ireland in 2006 to that in 2007?
Offer a terse response. 0.99. What is the ratio of the Female Labor Force(as % of total labor force) in Singapore in 2006 to that in 2007?
Ensure brevity in your answer.  1. What is the ratio of the Female Labor Force(as % of total labor force) of Ireland in 2006 to that in 2008?
Give a very brief answer. 0.98. What is the ratio of the Female Labor Force(as % of total labor force) in Singapore in 2006 to that in 2008?
Provide a succinct answer. 0.99. What is the ratio of the Female Labor Force(as % of total labor force) of Singapore in 2007 to that in 2008?
Ensure brevity in your answer.  0.99. What is the difference between the highest and the second highest Female Labor Force(as % of total labor force) of Central African Republic?
Your answer should be compact. 0.1. What is the difference between the highest and the second highest Female Labor Force(as % of total labor force) in Ireland?
Make the answer very short. 0.3. What is the difference between the highest and the second highest Female Labor Force(as % of total labor force) in Singapore?
Ensure brevity in your answer.  0.55. What is the difference between the highest and the lowest Female Labor Force(as % of total labor force) in Central African Republic?
Your answer should be compact. 0.47. What is the difference between the highest and the lowest Female Labor Force(as % of total labor force) of Ireland?
Offer a very short reply. 2.49. What is the difference between the highest and the lowest Female Labor Force(as % of total labor force) of Singapore?
Provide a short and direct response. 2.76. 